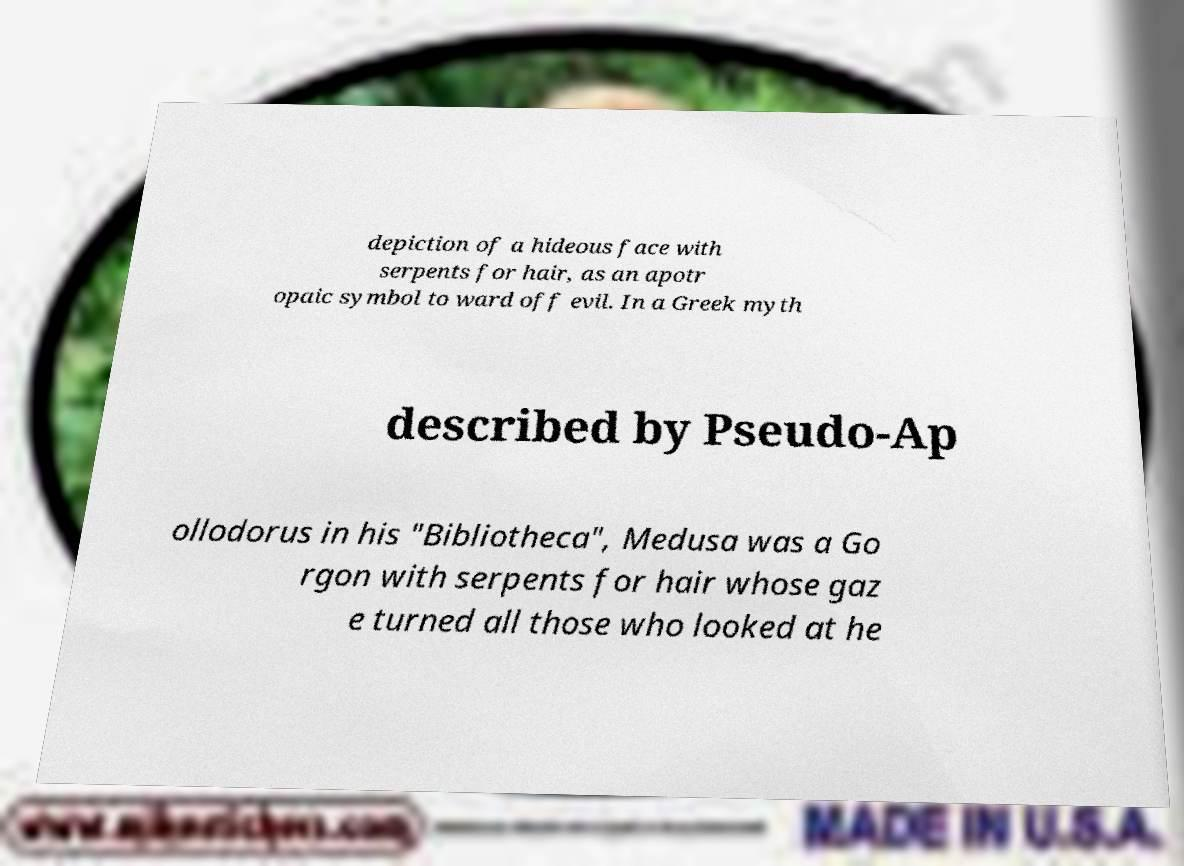Can you read and provide the text displayed in the image?This photo seems to have some interesting text. Can you extract and type it out for me? depiction of a hideous face with serpents for hair, as an apotr opaic symbol to ward off evil. In a Greek myth described by Pseudo-Ap ollodorus in his "Bibliotheca", Medusa was a Go rgon with serpents for hair whose gaz e turned all those who looked at he 